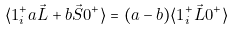<formula> <loc_0><loc_0><loc_500><loc_500>\langle 1 ^ { + } _ { i } a \vec { L } + b \vec { S } 0 ^ { + } \rangle = ( a - b ) \langle 1 ^ { + } _ { i } \vec { L } 0 ^ { + } \rangle</formula> 